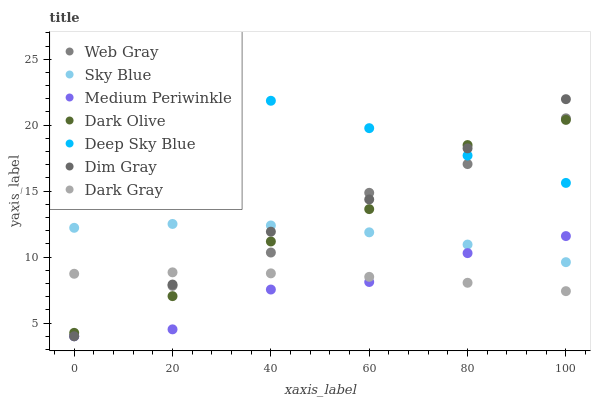Does Medium Periwinkle have the minimum area under the curve?
Answer yes or no. Yes. Does Deep Sky Blue have the maximum area under the curve?
Answer yes or no. Yes. Does Dark Olive have the minimum area under the curve?
Answer yes or no. No. Does Dark Olive have the maximum area under the curve?
Answer yes or no. No. Is Deep Sky Blue the smoothest?
Answer yes or no. Yes. Is Dark Olive the roughest?
Answer yes or no. Yes. Is Medium Periwinkle the smoothest?
Answer yes or no. No. Is Medium Periwinkle the roughest?
Answer yes or no. No. Does Dim Gray have the lowest value?
Answer yes or no. Yes. Does Dark Olive have the lowest value?
Answer yes or no. No. Does Deep Sky Blue have the highest value?
Answer yes or no. Yes. Does Dark Olive have the highest value?
Answer yes or no. No. Is Sky Blue less than Deep Sky Blue?
Answer yes or no. Yes. Is Deep Sky Blue greater than Sky Blue?
Answer yes or no. Yes. Does Dim Gray intersect Dark Olive?
Answer yes or no. Yes. Is Dim Gray less than Dark Olive?
Answer yes or no. No. Is Dim Gray greater than Dark Olive?
Answer yes or no. No. Does Sky Blue intersect Deep Sky Blue?
Answer yes or no. No. 